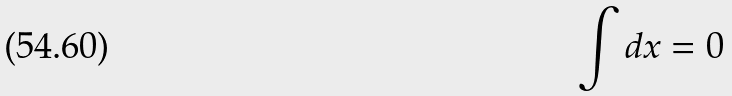<formula> <loc_0><loc_0><loc_500><loc_500>\int d x = 0</formula> 